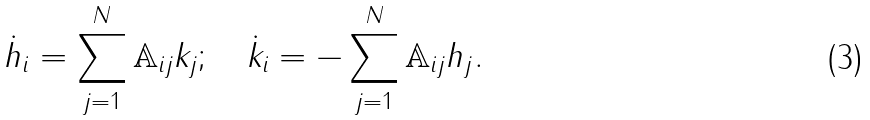<formula> <loc_0><loc_0><loc_500><loc_500>\dot { h } _ { i } = \sum _ { j = 1 } ^ { N } { \mathbb { A } } _ { i j } k _ { j } ; \quad \dot { k } _ { i } = - \sum _ { j = 1 } ^ { N } { \mathbb { A } } _ { i j } h _ { j } .</formula> 